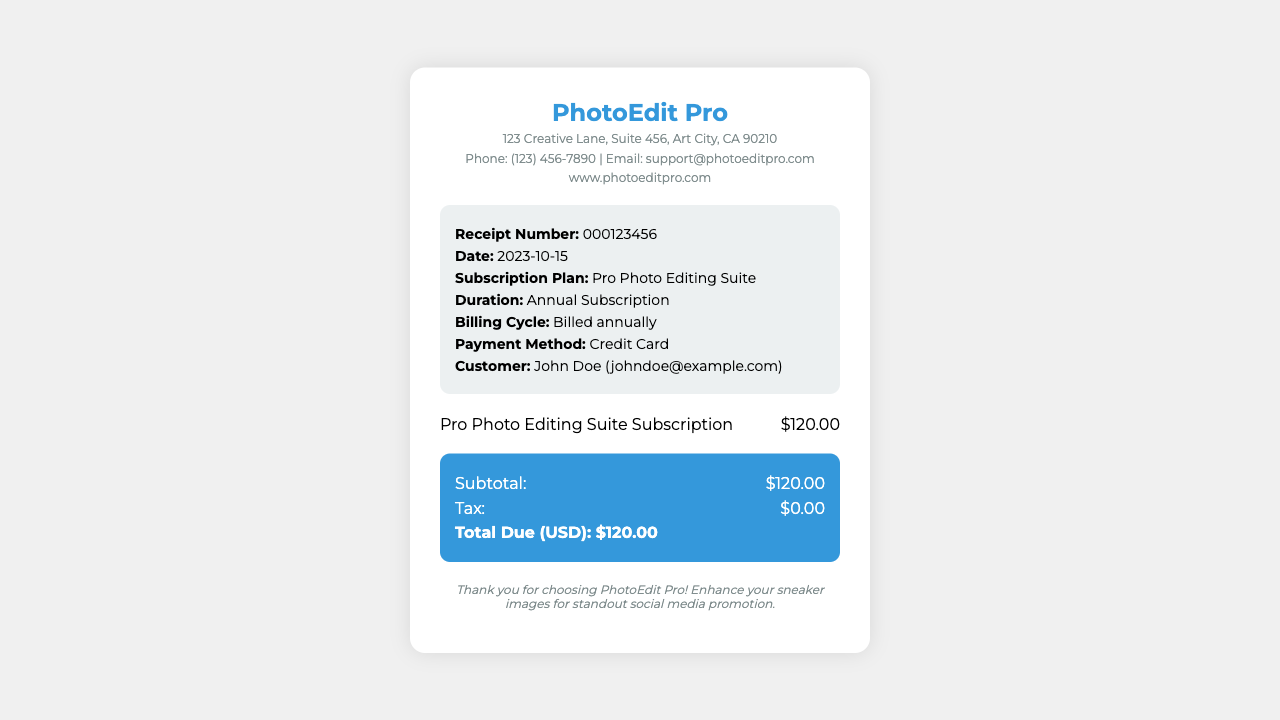What is the receipt number? The receipt number is identified in the transaction details section, which is 000123456.
Answer: 000123456 What is the total due? The total due is calculated from the summary section; it states the total amount as $120.00.
Answer: $120.00 Who is the customer? The customer's name is mentioned in the transaction details section, which shows John Doe.
Answer: John Doe What is the subscription plan? The specific plan subscribed to is provided in the transaction details; it is called Pro Photo Editing Suite.
Answer: Pro Photo Editing Suite When was the subscription billed? The billing cycle is indicated in the transaction details as billed annually, specifically dated 2023-10-15.
Answer: 2023-10-15 What is the duration of the subscription? The duration of the subscription can be found in the transaction details, indicating it is an annual subscription.
Answer: Annual Subscription What payment method was used? The payment method is specified in the transaction details; it shows that a credit card was used.
Answer: Credit Card What is the subtotal? The subtotal amount can be found in the summary section, listed as $120.00.
Answer: $120.00 What company issued this receipt? The header of the document identifies the company as PhotoEdit Pro.
Answer: PhotoEdit Pro 